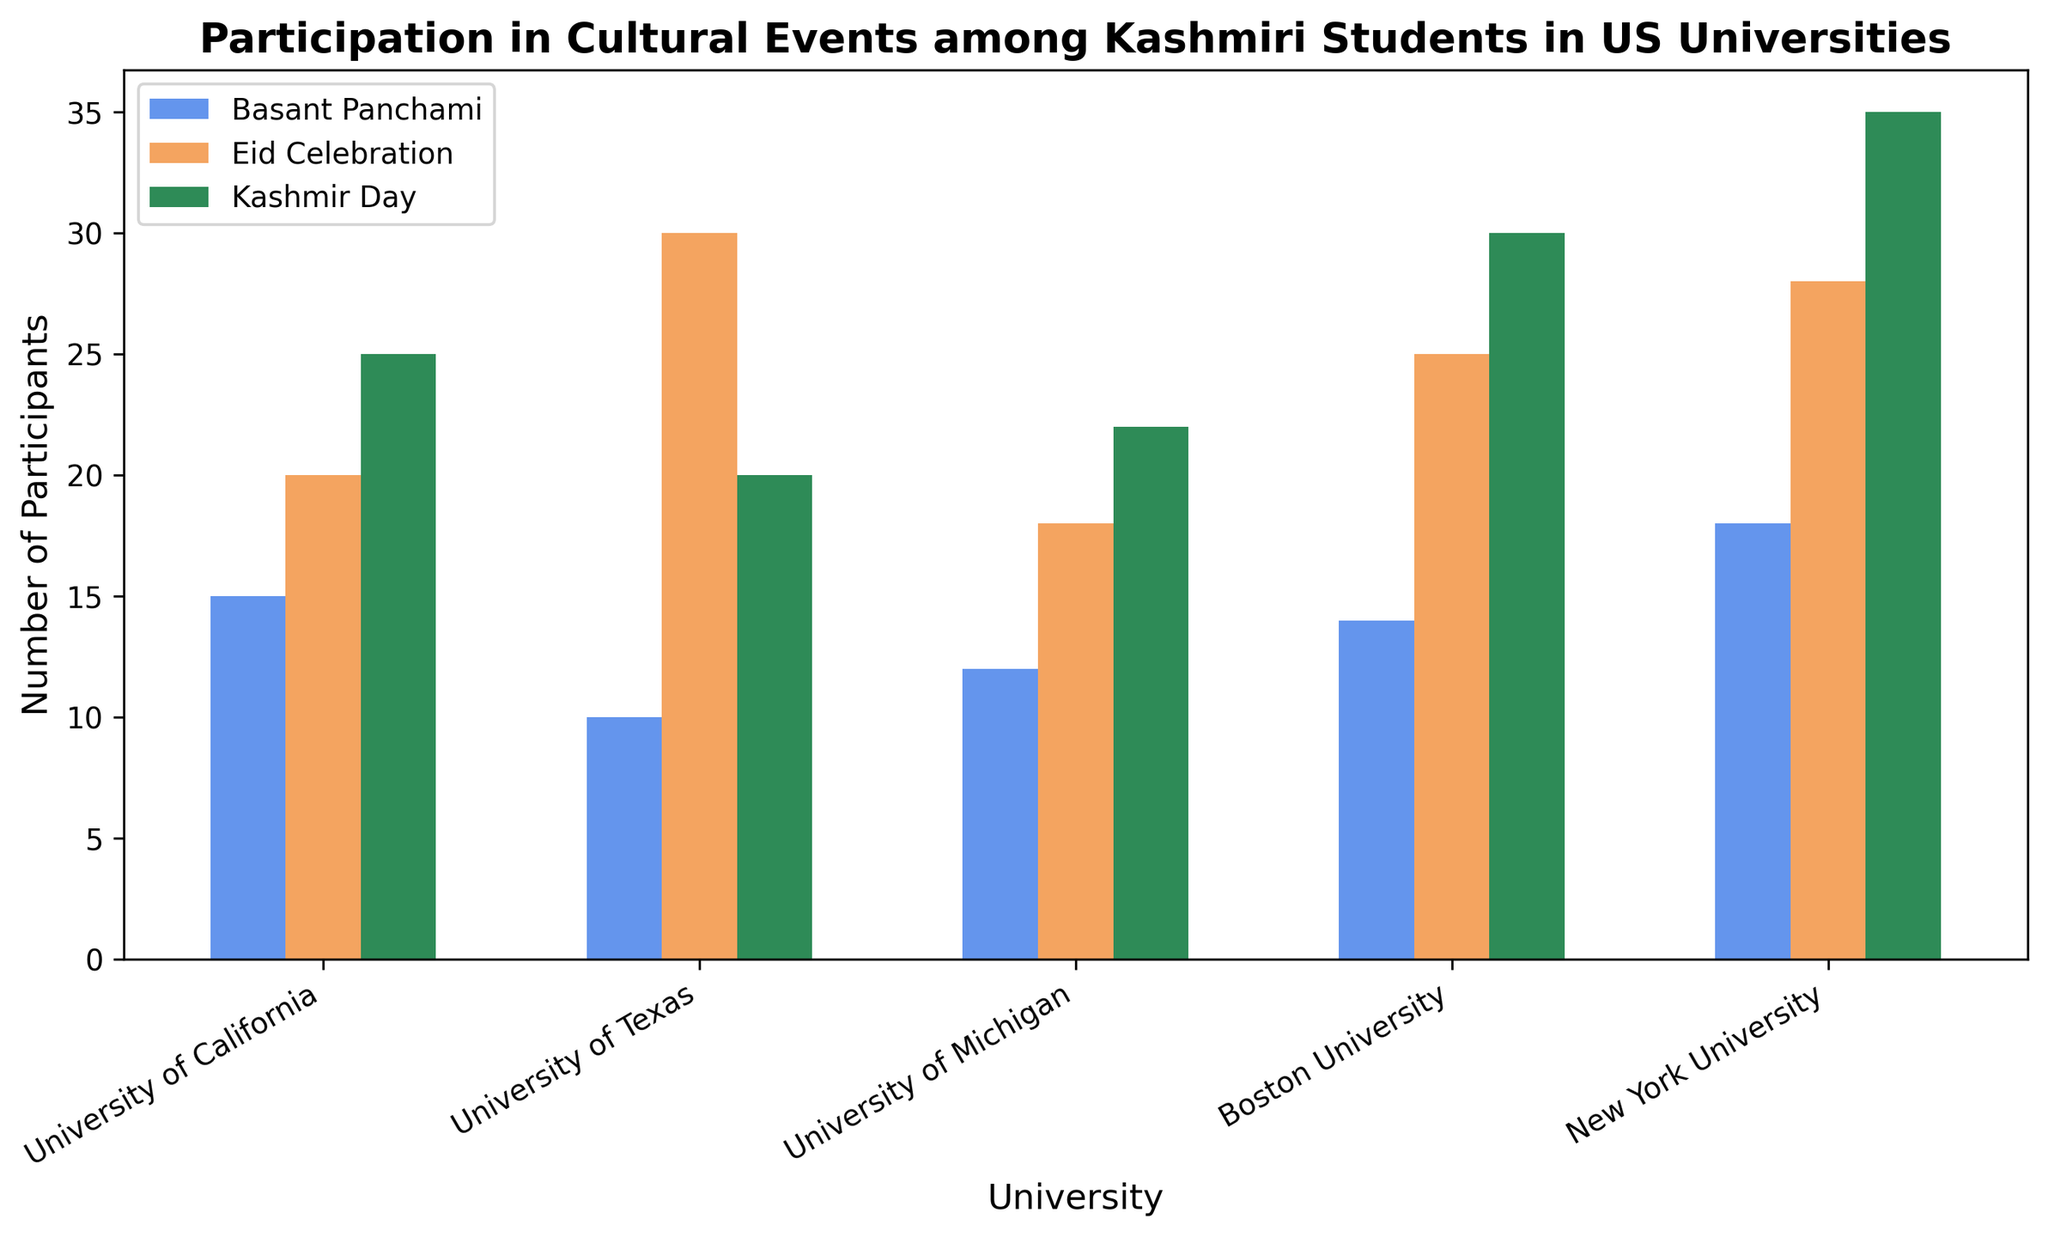Which university had the highest number of participants for the Kashmir Day event? To find the university with the highest number of participants for the Kashmir Day event, we compare the heights of the bars representing the Kashmir Day event across all universities. According to the figure, New York University had the highest bar, indicating the highest participation.
Answer: New York University Between the Eid Celebration event at the University of California and the Basant Panchami event at Boston University, which had the higher number of participants? We need to compare the height of the Eid Celebration bar at the University of California to the Basant Panchami bar at Boston University. The Eid Celebration event at UC has a bar height representing 20 participants, while the Basant Panchami event at Boston University has a bar height representing 14 participants.
Answer: Eid Celebration at University of California What's the total number of participants for all events at the University of Texas? To find the total, we sum the number of participants for all three events at the University of Texas. The numbers are: Basant Panchami (10), Eid Celebration (30), and Kashmir Day (20). Adding these together yields 10 + 30 + 20 = 60.
Answer: 60 What is the average number of participants for Eid Celebration events across all universities? To find the average number of participants, we sum the participants for Eid Celebration from all universities and then divide by the number of universities. The participants are: 20 (UC), 30 (UT), 18 (UM), 25 (BU), and 28 (NYU). The total is 121. There are 5 universities, so the average is 121/5 = 24.2.
Answer: 24.2 Which event had the most participants at Boston University? To determine this, we compare the heights of the bars for Basant Panchami, Eid Celebration, and Kashmir Day at Boston University. The Kashmir Day bar has the greatest height, indicating the highest number of participants.
Answer: Kashmir Day How does the number of participants for Eid Celebration at New York University compare to that at the University of Michigan? We compare the height of the Eid Celebration bars for New York University and the University of Michigan. New York University's bar represents 28 participants, and the University of Michigan's bar represents 18 participants. New York University had more participants.
Answer: New York University had more participants What is the total number of participants for Eid Celebration events and Kashmir Day events at all universities combined? First, we sum the participants for the Eid Celebration event across all universities and then do the same for the Kashmir Day event. For Eid Celebration: 20 (UC) + 30 (UT) + 18 (UM) + 25 (BU) + 28 (NYU) = 121. For Kashmir Day: 25 (UC) + 20 (UT) + 22 (UM) + 30 (BU) + 35 (NYU) = 132. The combined total is 121 + 132 = 253.
Answer: 253 